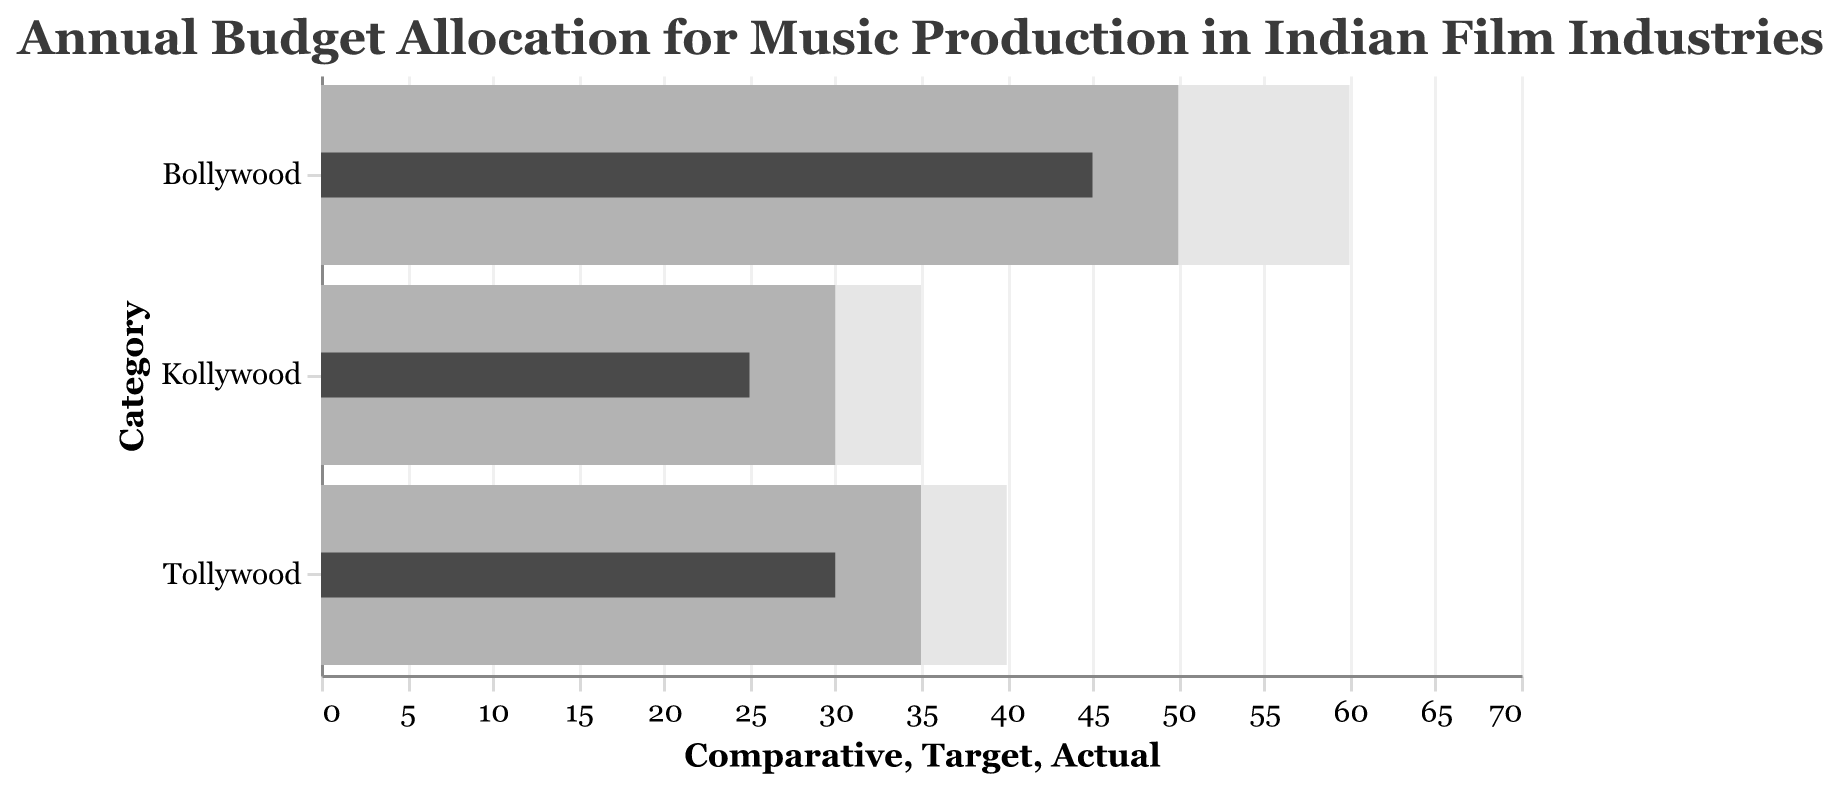What is the title of the figure? The title appears at the top of the figure, usually in larger and bold font, conveying the subject of the visualization. In this case, it reads "Annual Budget Allocation for Music Production in Indian Film Industries."
Answer: Annual Budget Allocation for Music Production in Indian Film Industries Which film industry has the highest actual budget allocation for music production? By observing the 'Actual' values on the chart, we see the bars explicitly indicating the amounts. Bollywood has the highest value at 45.
Answer: Bollywood How does Tollywood's actual budget compare to its target budget for music production? Tollywood's actual budget is 30, while its target budget is 35. Therefore, Tollywood's actual budget is below its target by 5 units.
Answer: 5 units below What is the difference between the target and comparative budgets for Kollywood? Kollywood has a target budget of 30 and a comparative budget of 35. The difference is calculated as 35 - 30.
Answer: 5 Which film industry has its actual budget closest to its target budget? By examining the differences between the actual and target budgets for each category:
- Bollywood: 50 - 45 = 5
- Tollywood: 35 - 30 = 5
- Kollywood: 30 - 25 = 5
All industries have the same difference, 5.
Answer: All industries What is the combined actual budget for music production across all three film industries? Sum the actual budgets:
- Bollywood: 45
- Tollywood: 30
- Kollywood: 25
Thus, 45 + 30 + 25.
Answer: 100 units Which industry has the smallest gap between its actual and comparative budgets? Calculate the gaps and compare:
- Bollywood: 60 - 45 = 15
- Tollywood: 40 - 30 = 10
- Kollywood: 35 - 25 = 10
Tollywood and Kollywood have the smallest gap, both at 10 units.
Answer: Tollywood and Kollywood In terms of comparative budgets, which film industry has the highest allocation? By viewing the 'Comparative' bar, one can identify that Bollywood has the highest value at 60 units.
Answer: Bollywood What is the mean (average) target budget for the three film industries? Sum the target budgets and divide by the number of industries:
- Bollywood: 50
- Tollywood: 35
- Kollywood: 30
Thus, (50 + 35 + 30) / 3.
Answer: 38.33 units If the actual budget for Bollywood increased by 10 units, what would be the new actual budget? Bollywood's current actual budget is 45. Adding 10 units, the new actual budget would be 45 + 10.
Answer: 55 units 